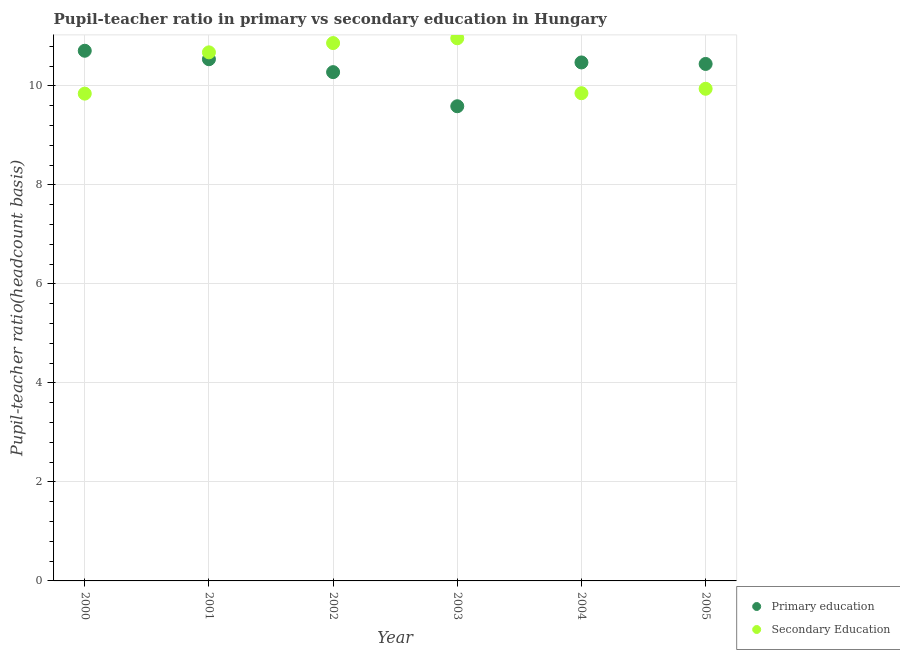Is the number of dotlines equal to the number of legend labels?
Offer a very short reply. Yes. What is the pupil-teacher ratio in primary education in 2000?
Your answer should be compact. 10.71. Across all years, what is the maximum pupil teacher ratio on secondary education?
Your response must be concise. 10.96. Across all years, what is the minimum pupil-teacher ratio in primary education?
Your response must be concise. 9.59. In which year was the pupil teacher ratio on secondary education maximum?
Ensure brevity in your answer.  2003. In which year was the pupil teacher ratio on secondary education minimum?
Ensure brevity in your answer.  2000. What is the total pupil-teacher ratio in primary education in the graph?
Give a very brief answer. 62.03. What is the difference between the pupil-teacher ratio in primary education in 2000 and that in 2003?
Your response must be concise. 1.12. What is the difference between the pupil-teacher ratio in primary education in 2001 and the pupil teacher ratio on secondary education in 2002?
Make the answer very short. -0.33. What is the average pupil teacher ratio on secondary education per year?
Offer a very short reply. 10.36. In the year 2001, what is the difference between the pupil-teacher ratio in primary education and pupil teacher ratio on secondary education?
Offer a very short reply. -0.14. In how many years, is the pupil-teacher ratio in primary education greater than 2.4?
Ensure brevity in your answer.  6. What is the ratio of the pupil teacher ratio on secondary education in 2001 to that in 2005?
Keep it short and to the point. 1.07. Is the pupil-teacher ratio in primary education in 2003 less than that in 2004?
Your response must be concise. Yes. Is the difference between the pupil teacher ratio on secondary education in 2003 and 2005 greater than the difference between the pupil-teacher ratio in primary education in 2003 and 2005?
Offer a terse response. Yes. What is the difference between the highest and the second highest pupil teacher ratio on secondary education?
Your answer should be compact. 0.1. What is the difference between the highest and the lowest pupil-teacher ratio in primary education?
Offer a very short reply. 1.12. In how many years, is the pupil teacher ratio on secondary education greater than the average pupil teacher ratio on secondary education taken over all years?
Offer a very short reply. 3. Does the pupil-teacher ratio in primary education monotonically increase over the years?
Ensure brevity in your answer.  No. Is the pupil teacher ratio on secondary education strictly less than the pupil-teacher ratio in primary education over the years?
Your answer should be compact. No. How many years are there in the graph?
Give a very brief answer. 6. Are the values on the major ticks of Y-axis written in scientific E-notation?
Ensure brevity in your answer.  No. Does the graph contain any zero values?
Give a very brief answer. No. Does the graph contain grids?
Offer a terse response. Yes. How are the legend labels stacked?
Keep it short and to the point. Vertical. What is the title of the graph?
Offer a very short reply. Pupil-teacher ratio in primary vs secondary education in Hungary. Does "Central government" appear as one of the legend labels in the graph?
Make the answer very short. No. What is the label or title of the Y-axis?
Provide a short and direct response. Pupil-teacher ratio(headcount basis). What is the Pupil-teacher ratio(headcount basis) in Primary education in 2000?
Give a very brief answer. 10.71. What is the Pupil-teacher ratio(headcount basis) in Secondary Education in 2000?
Your answer should be very brief. 9.84. What is the Pupil-teacher ratio(headcount basis) of Primary education in 2001?
Make the answer very short. 10.54. What is the Pupil-teacher ratio(headcount basis) in Secondary Education in 2001?
Ensure brevity in your answer.  10.68. What is the Pupil-teacher ratio(headcount basis) in Primary education in 2002?
Provide a short and direct response. 10.28. What is the Pupil-teacher ratio(headcount basis) in Secondary Education in 2002?
Keep it short and to the point. 10.86. What is the Pupil-teacher ratio(headcount basis) in Primary education in 2003?
Make the answer very short. 9.59. What is the Pupil-teacher ratio(headcount basis) of Secondary Education in 2003?
Provide a succinct answer. 10.96. What is the Pupil-teacher ratio(headcount basis) in Primary education in 2004?
Your answer should be compact. 10.47. What is the Pupil-teacher ratio(headcount basis) in Secondary Education in 2004?
Offer a very short reply. 9.85. What is the Pupil-teacher ratio(headcount basis) in Primary education in 2005?
Ensure brevity in your answer.  10.44. What is the Pupil-teacher ratio(headcount basis) of Secondary Education in 2005?
Your answer should be compact. 9.94. Across all years, what is the maximum Pupil-teacher ratio(headcount basis) in Primary education?
Ensure brevity in your answer.  10.71. Across all years, what is the maximum Pupil-teacher ratio(headcount basis) in Secondary Education?
Your response must be concise. 10.96. Across all years, what is the minimum Pupil-teacher ratio(headcount basis) of Primary education?
Ensure brevity in your answer.  9.59. Across all years, what is the minimum Pupil-teacher ratio(headcount basis) of Secondary Education?
Give a very brief answer. 9.84. What is the total Pupil-teacher ratio(headcount basis) in Primary education in the graph?
Your answer should be very brief. 62.03. What is the total Pupil-teacher ratio(headcount basis) in Secondary Education in the graph?
Offer a terse response. 62.14. What is the difference between the Pupil-teacher ratio(headcount basis) of Primary education in 2000 and that in 2001?
Provide a short and direct response. 0.17. What is the difference between the Pupil-teacher ratio(headcount basis) in Secondary Education in 2000 and that in 2001?
Provide a succinct answer. -0.83. What is the difference between the Pupil-teacher ratio(headcount basis) in Primary education in 2000 and that in 2002?
Make the answer very short. 0.43. What is the difference between the Pupil-teacher ratio(headcount basis) in Secondary Education in 2000 and that in 2002?
Your answer should be very brief. -1.02. What is the difference between the Pupil-teacher ratio(headcount basis) of Primary education in 2000 and that in 2003?
Offer a terse response. 1.12. What is the difference between the Pupil-teacher ratio(headcount basis) of Secondary Education in 2000 and that in 2003?
Make the answer very short. -1.12. What is the difference between the Pupil-teacher ratio(headcount basis) of Primary education in 2000 and that in 2004?
Make the answer very short. 0.24. What is the difference between the Pupil-teacher ratio(headcount basis) in Secondary Education in 2000 and that in 2004?
Ensure brevity in your answer.  -0.01. What is the difference between the Pupil-teacher ratio(headcount basis) in Primary education in 2000 and that in 2005?
Provide a succinct answer. 0.27. What is the difference between the Pupil-teacher ratio(headcount basis) of Secondary Education in 2000 and that in 2005?
Provide a short and direct response. -0.1. What is the difference between the Pupil-teacher ratio(headcount basis) of Primary education in 2001 and that in 2002?
Ensure brevity in your answer.  0.26. What is the difference between the Pupil-teacher ratio(headcount basis) of Secondary Education in 2001 and that in 2002?
Offer a terse response. -0.19. What is the difference between the Pupil-teacher ratio(headcount basis) in Primary education in 2001 and that in 2003?
Your answer should be compact. 0.95. What is the difference between the Pupil-teacher ratio(headcount basis) of Secondary Education in 2001 and that in 2003?
Your answer should be compact. -0.28. What is the difference between the Pupil-teacher ratio(headcount basis) of Primary education in 2001 and that in 2004?
Make the answer very short. 0.07. What is the difference between the Pupil-teacher ratio(headcount basis) of Secondary Education in 2001 and that in 2004?
Offer a very short reply. 0.83. What is the difference between the Pupil-teacher ratio(headcount basis) of Primary education in 2001 and that in 2005?
Provide a short and direct response. 0.1. What is the difference between the Pupil-teacher ratio(headcount basis) in Secondary Education in 2001 and that in 2005?
Provide a succinct answer. 0.74. What is the difference between the Pupil-teacher ratio(headcount basis) of Primary education in 2002 and that in 2003?
Keep it short and to the point. 0.69. What is the difference between the Pupil-teacher ratio(headcount basis) of Secondary Education in 2002 and that in 2003?
Make the answer very short. -0.1. What is the difference between the Pupil-teacher ratio(headcount basis) in Primary education in 2002 and that in 2004?
Make the answer very short. -0.2. What is the difference between the Pupil-teacher ratio(headcount basis) in Secondary Education in 2002 and that in 2004?
Make the answer very short. 1.01. What is the difference between the Pupil-teacher ratio(headcount basis) in Primary education in 2002 and that in 2005?
Provide a succinct answer. -0.17. What is the difference between the Pupil-teacher ratio(headcount basis) of Secondary Education in 2002 and that in 2005?
Give a very brief answer. 0.92. What is the difference between the Pupil-teacher ratio(headcount basis) in Primary education in 2003 and that in 2004?
Make the answer very short. -0.88. What is the difference between the Pupil-teacher ratio(headcount basis) in Secondary Education in 2003 and that in 2004?
Your answer should be compact. 1.11. What is the difference between the Pupil-teacher ratio(headcount basis) in Primary education in 2003 and that in 2005?
Offer a terse response. -0.85. What is the difference between the Pupil-teacher ratio(headcount basis) in Secondary Education in 2003 and that in 2005?
Ensure brevity in your answer.  1.02. What is the difference between the Pupil-teacher ratio(headcount basis) in Primary education in 2004 and that in 2005?
Provide a short and direct response. 0.03. What is the difference between the Pupil-teacher ratio(headcount basis) of Secondary Education in 2004 and that in 2005?
Give a very brief answer. -0.09. What is the difference between the Pupil-teacher ratio(headcount basis) of Primary education in 2000 and the Pupil-teacher ratio(headcount basis) of Secondary Education in 2001?
Ensure brevity in your answer.  0.03. What is the difference between the Pupil-teacher ratio(headcount basis) of Primary education in 2000 and the Pupil-teacher ratio(headcount basis) of Secondary Education in 2002?
Keep it short and to the point. -0.16. What is the difference between the Pupil-teacher ratio(headcount basis) of Primary education in 2000 and the Pupil-teacher ratio(headcount basis) of Secondary Education in 2003?
Make the answer very short. -0.25. What is the difference between the Pupil-teacher ratio(headcount basis) of Primary education in 2000 and the Pupil-teacher ratio(headcount basis) of Secondary Education in 2004?
Your answer should be compact. 0.86. What is the difference between the Pupil-teacher ratio(headcount basis) of Primary education in 2000 and the Pupil-teacher ratio(headcount basis) of Secondary Education in 2005?
Provide a succinct answer. 0.77. What is the difference between the Pupil-teacher ratio(headcount basis) of Primary education in 2001 and the Pupil-teacher ratio(headcount basis) of Secondary Education in 2002?
Your answer should be compact. -0.33. What is the difference between the Pupil-teacher ratio(headcount basis) in Primary education in 2001 and the Pupil-teacher ratio(headcount basis) in Secondary Education in 2003?
Make the answer very short. -0.42. What is the difference between the Pupil-teacher ratio(headcount basis) of Primary education in 2001 and the Pupil-teacher ratio(headcount basis) of Secondary Education in 2004?
Keep it short and to the point. 0.69. What is the difference between the Pupil-teacher ratio(headcount basis) of Primary education in 2001 and the Pupil-teacher ratio(headcount basis) of Secondary Education in 2005?
Make the answer very short. 0.6. What is the difference between the Pupil-teacher ratio(headcount basis) in Primary education in 2002 and the Pupil-teacher ratio(headcount basis) in Secondary Education in 2003?
Give a very brief answer. -0.68. What is the difference between the Pupil-teacher ratio(headcount basis) of Primary education in 2002 and the Pupil-teacher ratio(headcount basis) of Secondary Education in 2004?
Make the answer very short. 0.43. What is the difference between the Pupil-teacher ratio(headcount basis) of Primary education in 2002 and the Pupil-teacher ratio(headcount basis) of Secondary Education in 2005?
Ensure brevity in your answer.  0.34. What is the difference between the Pupil-teacher ratio(headcount basis) of Primary education in 2003 and the Pupil-teacher ratio(headcount basis) of Secondary Education in 2004?
Give a very brief answer. -0.26. What is the difference between the Pupil-teacher ratio(headcount basis) of Primary education in 2003 and the Pupil-teacher ratio(headcount basis) of Secondary Education in 2005?
Your answer should be very brief. -0.35. What is the difference between the Pupil-teacher ratio(headcount basis) of Primary education in 2004 and the Pupil-teacher ratio(headcount basis) of Secondary Education in 2005?
Your response must be concise. 0.53. What is the average Pupil-teacher ratio(headcount basis) in Primary education per year?
Keep it short and to the point. 10.34. What is the average Pupil-teacher ratio(headcount basis) in Secondary Education per year?
Keep it short and to the point. 10.36. In the year 2000, what is the difference between the Pupil-teacher ratio(headcount basis) of Primary education and Pupil-teacher ratio(headcount basis) of Secondary Education?
Your answer should be compact. 0.87. In the year 2001, what is the difference between the Pupil-teacher ratio(headcount basis) in Primary education and Pupil-teacher ratio(headcount basis) in Secondary Education?
Provide a succinct answer. -0.14. In the year 2002, what is the difference between the Pupil-teacher ratio(headcount basis) of Primary education and Pupil-teacher ratio(headcount basis) of Secondary Education?
Provide a succinct answer. -0.59. In the year 2003, what is the difference between the Pupil-teacher ratio(headcount basis) of Primary education and Pupil-teacher ratio(headcount basis) of Secondary Education?
Your answer should be compact. -1.37. In the year 2004, what is the difference between the Pupil-teacher ratio(headcount basis) in Primary education and Pupil-teacher ratio(headcount basis) in Secondary Education?
Your answer should be very brief. 0.62. In the year 2005, what is the difference between the Pupil-teacher ratio(headcount basis) of Primary education and Pupil-teacher ratio(headcount basis) of Secondary Education?
Provide a short and direct response. 0.5. What is the ratio of the Pupil-teacher ratio(headcount basis) in Primary education in 2000 to that in 2001?
Ensure brevity in your answer.  1.02. What is the ratio of the Pupil-teacher ratio(headcount basis) in Secondary Education in 2000 to that in 2001?
Ensure brevity in your answer.  0.92. What is the ratio of the Pupil-teacher ratio(headcount basis) of Primary education in 2000 to that in 2002?
Give a very brief answer. 1.04. What is the ratio of the Pupil-teacher ratio(headcount basis) of Secondary Education in 2000 to that in 2002?
Offer a terse response. 0.91. What is the ratio of the Pupil-teacher ratio(headcount basis) of Primary education in 2000 to that in 2003?
Your answer should be very brief. 1.12. What is the ratio of the Pupil-teacher ratio(headcount basis) of Secondary Education in 2000 to that in 2003?
Ensure brevity in your answer.  0.9. What is the ratio of the Pupil-teacher ratio(headcount basis) in Primary education in 2000 to that in 2004?
Ensure brevity in your answer.  1.02. What is the ratio of the Pupil-teacher ratio(headcount basis) of Secondary Education in 2000 to that in 2004?
Your response must be concise. 1. What is the ratio of the Pupil-teacher ratio(headcount basis) in Primary education in 2000 to that in 2005?
Ensure brevity in your answer.  1.03. What is the ratio of the Pupil-teacher ratio(headcount basis) of Primary education in 2001 to that in 2002?
Keep it short and to the point. 1.03. What is the ratio of the Pupil-teacher ratio(headcount basis) in Secondary Education in 2001 to that in 2002?
Ensure brevity in your answer.  0.98. What is the ratio of the Pupil-teacher ratio(headcount basis) in Primary education in 2001 to that in 2003?
Offer a very short reply. 1.1. What is the ratio of the Pupil-teacher ratio(headcount basis) of Secondary Education in 2001 to that in 2003?
Your answer should be very brief. 0.97. What is the ratio of the Pupil-teacher ratio(headcount basis) of Primary education in 2001 to that in 2004?
Keep it short and to the point. 1.01. What is the ratio of the Pupil-teacher ratio(headcount basis) in Secondary Education in 2001 to that in 2004?
Give a very brief answer. 1.08. What is the ratio of the Pupil-teacher ratio(headcount basis) of Primary education in 2001 to that in 2005?
Give a very brief answer. 1.01. What is the ratio of the Pupil-teacher ratio(headcount basis) in Secondary Education in 2001 to that in 2005?
Give a very brief answer. 1.07. What is the ratio of the Pupil-teacher ratio(headcount basis) of Primary education in 2002 to that in 2003?
Your answer should be compact. 1.07. What is the ratio of the Pupil-teacher ratio(headcount basis) in Primary education in 2002 to that in 2004?
Your answer should be compact. 0.98. What is the ratio of the Pupil-teacher ratio(headcount basis) in Secondary Education in 2002 to that in 2004?
Your answer should be very brief. 1.1. What is the ratio of the Pupil-teacher ratio(headcount basis) of Primary education in 2002 to that in 2005?
Provide a short and direct response. 0.98. What is the ratio of the Pupil-teacher ratio(headcount basis) of Secondary Education in 2002 to that in 2005?
Your answer should be compact. 1.09. What is the ratio of the Pupil-teacher ratio(headcount basis) in Primary education in 2003 to that in 2004?
Offer a very short reply. 0.92. What is the ratio of the Pupil-teacher ratio(headcount basis) of Secondary Education in 2003 to that in 2004?
Make the answer very short. 1.11. What is the ratio of the Pupil-teacher ratio(headcount basis) in Primary education in 2003 to that in 2005?
Make the answer very short. 0.92. What is the ratio of the Pupil-teacher ratio(headcount basis) in Secondary Education in 2003 to that in 2005?
Provide a short and direct response. 1.1. What is the difference between the highest and the second highest Pupil-teacher ratio(headcount basis) in Primary education?
Keep it short and to the point. 0.17. What is the difference between the highest and the second highest Pupil-teacher ratio(headcount basis) of Secondary Education?
Your answer should be very brief. 0.1. What is the difference between the highest and the lowest Pupil-teacher ratio(headcount basis) of Primary education?
Your answer should be compact. 1.12. What is the difference between the highest and the lowest Pupil-teacher ratio(headcount basis) in Secondary Education?
Provide a short and direct response. 1.12. 